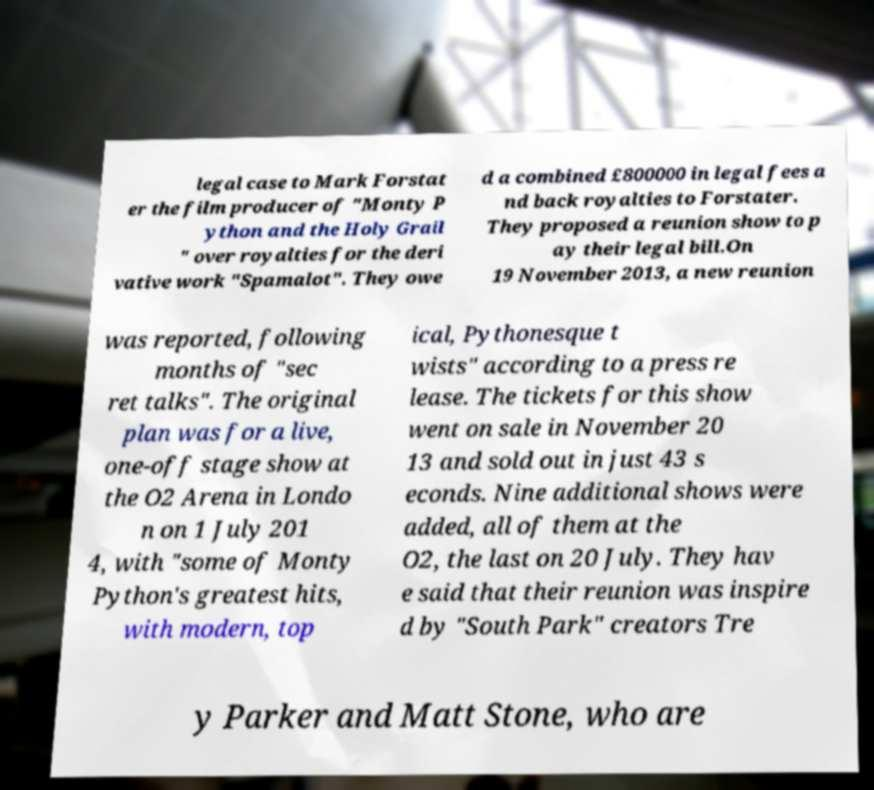Could you assist in decoding the text presented in this image and type it out clearly? legal case to Mark Forstat er the film producer of "Monty P ython and the Holy Grail " over royalties for the deri vative work "Spamalot". They owe d a combined £800000 in legal fees a nd back royalties to Forstater. They proposed a reunion show to p ay their legal bill.On 19 November 2013, a new reunion was reported, following months of "sec ret talks". The original plan was for a live, one-off stage show at the O2 Arena in Londo n on 1 July 201 4, with "some of Monty Python's greatest hits, with modern, top ical, Pythonesque t wists" according to a press re lease. The tickets for this show went on sale in November 20 13 and sold out in just 43 s econds. Nine additional shows were added, all of them at the O2, the last on 20 July. They hav e said that their reunion was inspire d by "South Park" creators Tre y Parker and Matt Stone, who are 